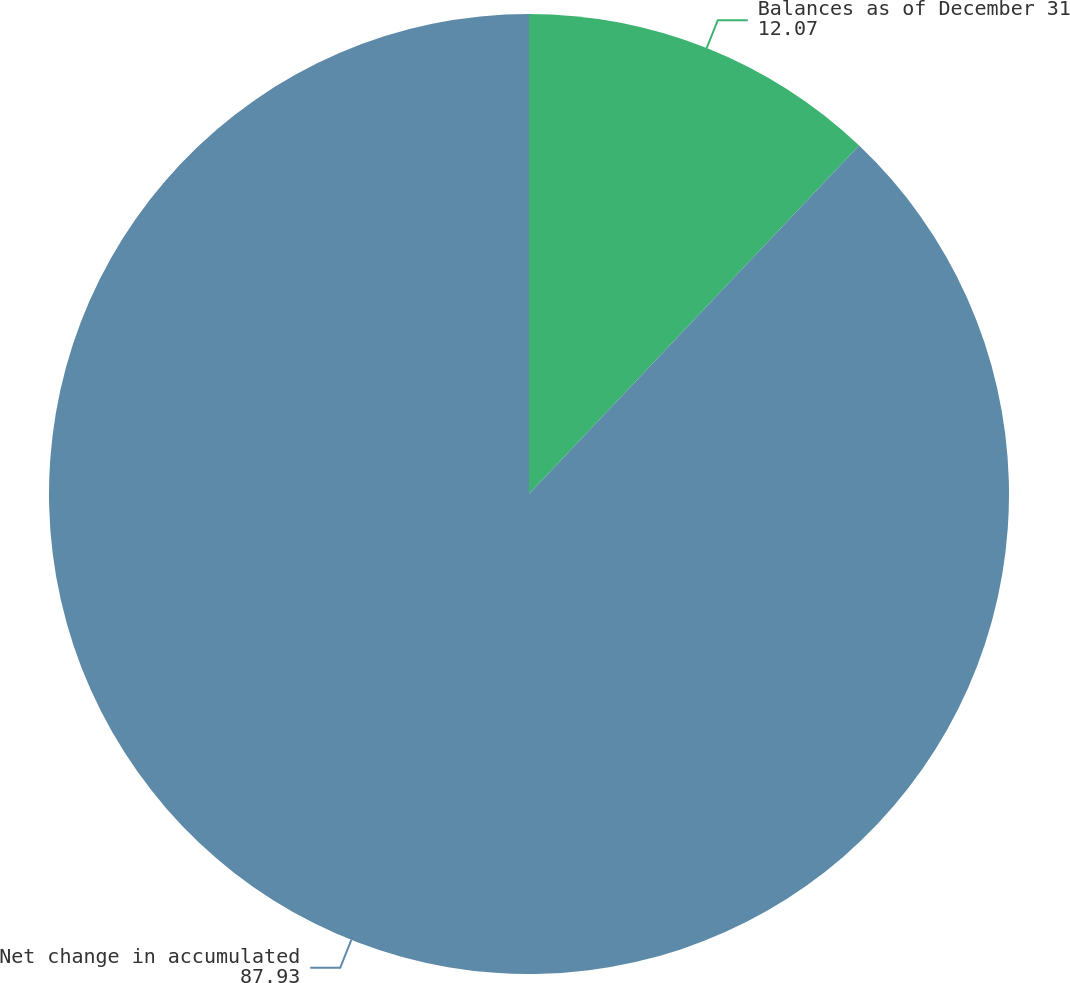Convert chart to OTSL. <chart><loc_0><loc_0><loc_500><loc_500><pie_chart><fcel>Balances as of December 31<fcel>Net change in accumulated<nl><fcel>12.07%<fcel>87.93%<nl></chart> 